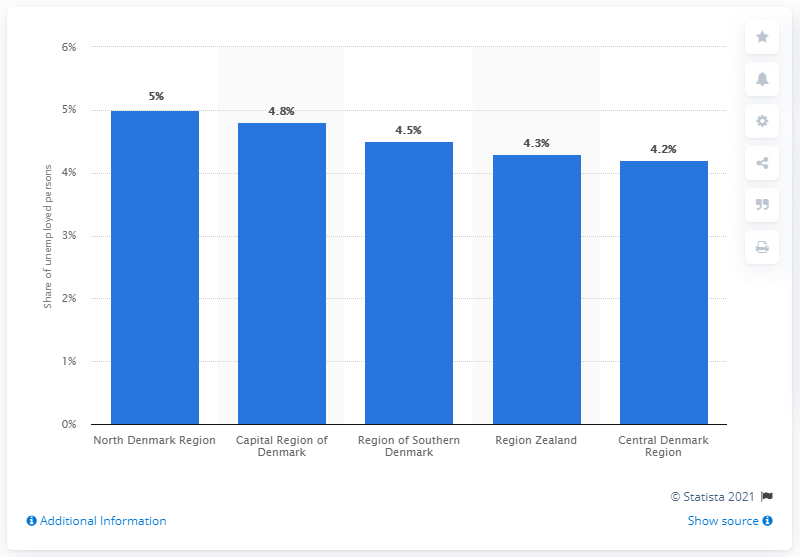Identify some key points in this picture. In 2020, the Capital Region of Denmark had the highest unemployment rate among all regions in Denmark. The unemployment rate in the Capital Region of Denmark was 4.8% in 2020. In 2020, the majority of unemployed individuals in Denmark came from the North Denmark Region. 